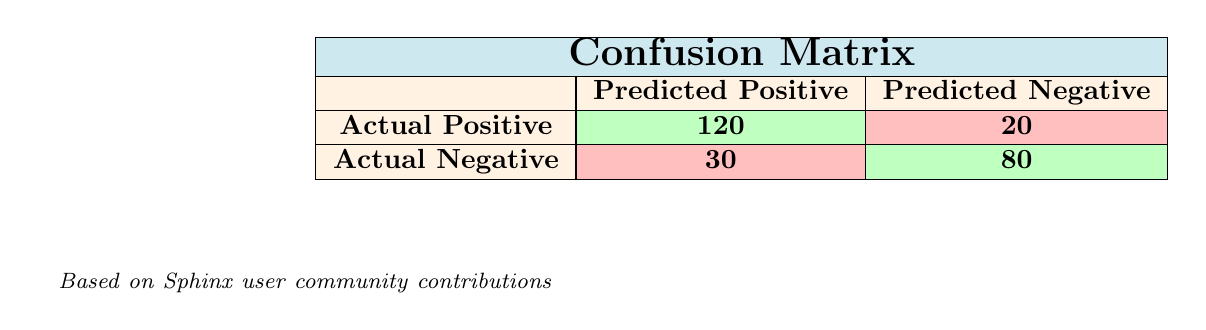What is the total number of actual positive cases? The total number of actual positive cases is indicated in the confusion matrix as "Actual Positive," which shows a count of 120 true positives plus 20 false negatives. Therefore, the total number of actual positive cases is 120 + 20 = 140.
Answer: 140 How many actual negative cases are represented in the table? According to the confusion matrix, "Actual Negative" consists of 30 false positives and 80 true negatives. Thus, the total number of actual negative cases is 30 + 80 = 110.
Answer: 110 Is the number of true positives greater than the number of true negatives? The table shows 120 true positives and 80 true negatives. Since 120 is greater than 80, the statement is true.
Answer: Yes What is the false positive rate in this dataset? The false positive rate can be calculated using the formula: false positive rate = false positives / (false positives + true negatives). From the table, there are 30 false positives and 80 true negatives, so the false positive rate is 30 / (30 + 80) = 30 / 110 ≈ 0.273 or 27.3%.
Answer: 27.3% How many total contributions resulted in unresolved cases? The table provides 30 false positives and 20 false negatives, which reflect the contributions that were not effective in resolving bugs. Therefore, the total number of unresolved cases is 30 + 20 = 50 contributions.
Answer: 50 Calculate the total number of successful resolutions. For successful resolutions, we sum the true positives which is indicated in the table as 120. Hence, the total number of successful resolutions is simply 120.
Answer: 120 Are there more successful bug resolutions than failures in the community contributions? Based on the confusion matrix, successful resolutions (true positives) are 120 and failures (false negatives) are 20. Since 120 is greater than 20, the statement is true.
Answer: Yes What percentage of the predicted positives were actually correct? To determine the percentage of predicted positives that were actual true positives, we use the formula: (true positives / predicted positives) * 100. The total predicted positives is 120 true positives + 30 false positives = 150. Thus, the percentage is (120 / 150) * 100 = 80%.
Answer: 80% 